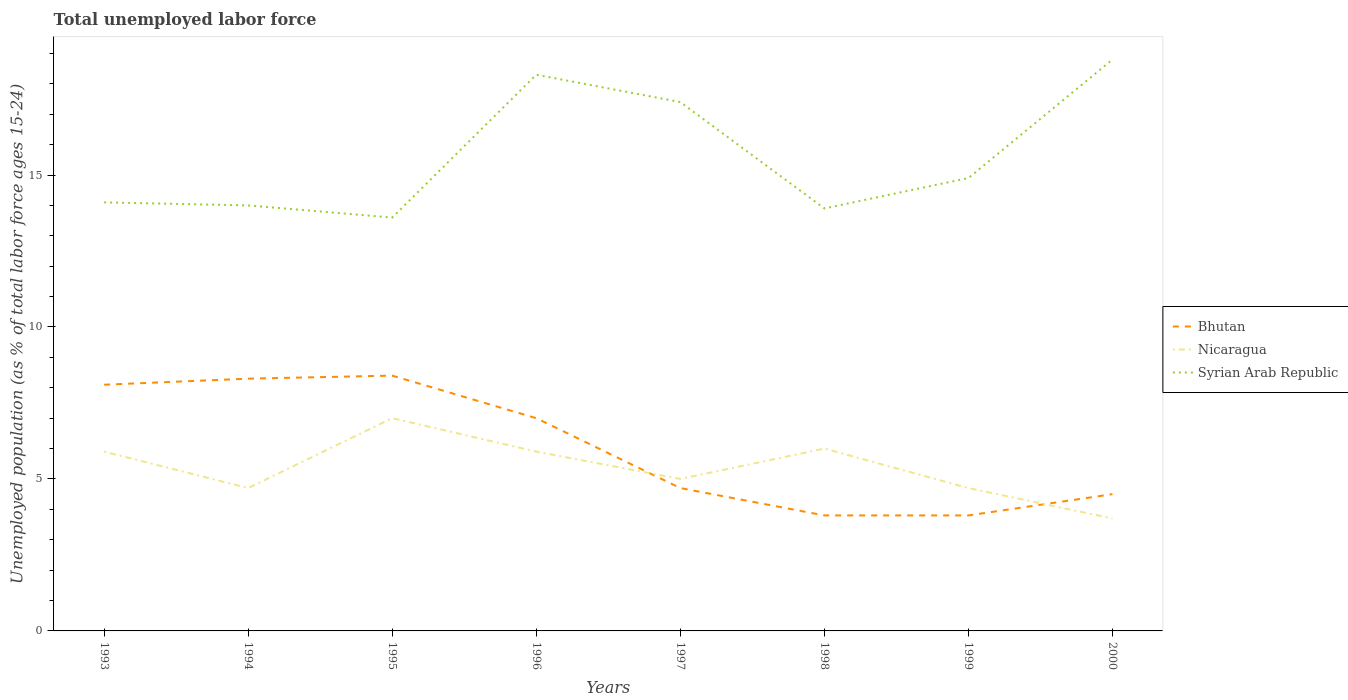How many different coloured lines are there?
Ensure brevity in your answer.  3. Is the number of lines equal to the number of legend labels?
Your answer should be very brief. Yes. Across all years, what is the maximum percentage of unemployed population in in Bhutan?
Provide a succinct answer. 3.8. In which year was the percentage of unemployed population in in Syrian Arab Republic maximum?
Make the answer very short. 1995. What is the total percentage of unemployed population in in Syrian Arab Republic in the graph?
Ensure brevity in your answer.  -5.2. What is the difference between the highest and the second highest percentage of unemployed population in in Bhutan?
Provide a succinct answer. 4.6. What is the difference between the highest and the lowest percentage of unemployed population in in Bhutan?
Provide a succinct answer. 4. How many years are there in the graph?
Keep it short and to the point. 8. What is the difference between two consecutive major ticks on the Y-axis?
Give a very brief answer. 5. Where does the legend appear in the graph?
Your response must be concise. Center right. How many legend labels are there?
Offer a very short reply. 3. What is the title of the graph?
Offer a terse response. Total unemployed labor force. What is the label or title of the Y-axis?
Provide a short and direct response. Unemployed population (as % of total labor force ages 15-24). What is the Unemployed population (as % of total labor force ages 15-24) of Bhutan in 1993?
Provide a short and direct response. 8.1. What is the Unemployed population (as % of total labor force ages 15-24) in Nicaragua in 1993?
Give a very brief answer. 5.9. What is the Unemployed population (as % of total labor force ages 15-24) in Syrian Arab Republic in 1993?
Offer a terse response. 14.1. What is the Unemployed population (as % of total labor force ages 15-24) of Bhutan in 1994?
Your answer should be very brief. 8.3. What is the Unemployed population (as % of total labor force ages 15-24) of Nicaragua in 1994?
Your response must be concise. 4.7. What is the Unemployed population (as % of total labor force ages 15-24) of Bhutan in 1995?
Offer a terse response. 8.4. What is the Unemployed population (as % of total labor force ages 15-24) in Syrian Arab Republic in 1995?
Offer a very short reply. 13.6. What is the Unemployed population (as % of total labor force ages 15-24) of Nicaragua in 1996?
Make the answer very short. 5.9. What is the Unemployed population (as % of total labor force ages 15-24) of Syrian Arab Republic in 1996?
Your answer should be very brief. 18.3. What is the Unemployed population (as % of total labor force ages 15-24) in Bhutan in 1997?
Your response must be concise. 4.7. What is the Unemployed population (as % of total labor force ages 15-24) of Syrian Arab Republic in 1997?
Provide a succinct answer. 17.4. What is the Unemployed population (as % of total labor force ages 15-24) of Bhutan in 1998?
Offer a terse response. 3.8. What is the Unemployed population (as % of total labor force ages 15-24) of Syrian Arab Republic in 1998?
Provide a succinct answer. 13.9. What is the Unemployed population (as % of total labor force ages 15-24) in Bhutan in 1999?
Your response must be concise. 3.8. What is the Unemployed population (as % of total labor force ages 15-24) of Nicaragua in 1999?
Keep it short and to the point. 4.7. What is the Unemployed population (as % of total labor force ages 15-24) of Syrian Arab Republic in 1999?
Your response must be concise. 14.9. What is the Unemployed population (as % of total labor force ages 15-24) in Bhutan in 2000?
Provide a succinct answer. 4.5. What is the Unemployed population (as % of total labor force ages 15-24) of Nicaragua in 2000?
Offer a terse response. 3.7. What is the Unemployed population (as % of total labor force ages 15-24) in Syrian Arab Republic in 2000?
Ensure brevity in your answer.  18.8. Across all years, what is the maximum Unemployed population (as % of total labor force ages 15-24) in Bhutan?
Offer a terse response. 8.4. Across all years, what is the maximum Unemployed population (as % of total labor force ages 15-24) in Syrian Arab Republic?
Provide a short and direct response. 18.8. Across all years, what is the minimum Unemployed population (as % of total labor force ages 15-24) in Bhutan?
Offer a terse response. 3.8. Across all years, what is the minimum Unemployed population (as % of total labor force ages 15-24) of Nicaragua?
Provide a short and direct response. 3.7. Across all years, what is the minimum Unemployed population (as % of total labor force ages 15-24) of Syrian Arab Republic?
Your answer should be very brief. 13.6. What is the total Unemployed population (as % of total labor force ages 15-24) of Bhutan in the graph?
Your response must be concise. 48.6. What is the total Unemployed population (as % of total labor force ages 15-24) in Nicaragua in the graph?
Keep it short and to the point. 42.9. What is the total Unemployed population (as % of total labor force ages 15-24) in Syrian Arab Republic in the graph?
Provide a succinct answer. 125. What is the difference between the Unemployed population (as % of total labor force ages 15-24) of Syrian Arab Republic in 1993 and that in 1994?
Your answer should be compact. 0.1. What is the difference between the Unemployed population (as % of total labor force ages 15-24) of Syrian Arab Republic in 1993 and that in 1995?
Give a very brief answer. 0.5. What is the difference between the Unemployed population (as % of total labor force ages 15-24) of Nicaragua in 1993 and that in 1996?
Provide a short and direct response. 0. What is the difference between the Unemployed population (as % of total labor force ages 15-24) in Bhutan in 1993 and that in 1997?
Ensure brevity in your answer.  3.4. What is the difference between the Unemployed population (as % of total labor force ages 15-24) of Nicaragua in 1993 and that in 1997?
Your answer should be very brief. 0.9. What is the difference between the Unemployed population (as % of total labor force ages 15-24) in Syrian Arab Republic in 1993 and that in 1997?
Keep it short and to the point. -3.3. What is the difference between the Unemployed population (as % of total labor force ages 15-24) of Nicaragua in 1993 and that in 1998?
Your response must be concise. -0.1. What is the difference between the Unemployed population (as % of total labor force ages 15-24) of Syrian Arab Republic in 1993 and that in 1998?
Provide a succinct answer. 0.2. What is the difference between the Unemployed population (as % of total labor force ages 15-24) in Bhutan in 1993 and that in 1999?
Your response must be concise. 4.3. What is the difference between the Unemployed population (as % of total labor force ages 15-24) in Nicaragua in 1993 and that in 1999?
Provide a short and direct response. 1.2. What is the difference between the Unemployed population (as % of total labor force ages 15-24) in Bhutan in 1993 and that in 2000?
Ensure brevity in your answer.  3.6. What is the difference between the Unemployed population (as % of total labor force ages 15-24) of Nicaragua in 1993 and that in 2000?
Ensure brevity in your answer.  2.2. What is the difference between the Unemployed population (as % of total labor force ages 15-24) in Syrian Arab Republic in 1993 and that in 2000?
Provide a succinct answer. -4.7. What is the difference between the Unemployed population (as % of total labor force ages 15-24) in Nicaragua in 1994 and that in 1995?
Provide a short and direct response. -2.3. What is the difference between the Unemployed population (as % of total labor force ages 15-24) of Syrian Arab Republic in 1994 and that in 1995?
Ensure brevity in your answer.  0.4. What is the difference between the Unemployed population (as % of total labor force ages 15-24) of Bhutan in 1994 and that in 1996?
Offer a very short reply. 1.3. What is the difference between the Unemployed population (as % of total labor force ages 15-24) of Nicaragua in 1994 and that in 1996?
Ensure brevity in your answer.  -1.2. What is the difference between the Unemployed population (as % of total labor force ages 15-24) in Syrian Arab Republic in 1994 and that in 1996?
Give a very brief answer. -4.3. What is the difference between the Unemployed population (as % of total labor force ages 15-24) of Nicaragua in 1994 and that in 1997?
Your answer should be very brief. -0.3. What is the difference between the Unemployed population (as % of total labor force ages 15-24) of Syrian Arab Republic in 1994 and that in 1997?
Make the answer very short. -3.4. What is the difference between the Unemployed population (as % of total labor force ages 15-24) of Bhutan in 1994 and that in 1998?
Your response must be concise. 4.5. What is the difference between the Unemployed population (as % of total labor force ages 15-24) of Nicaragua in 1994 and that in 1998?
Offer a very short reply. -1.3. What is the difference between the Unemployed population (as % of total labor force ages 15-24) in Syrian Arab Republic in 1994 and that in 1998?
Provide a succinct answer. 0.1. What is the difference between the Unemployed population (as % of total labor force ages 15-24) of Bhutan in 1994 and that in 1999?
Provide a short and direct response. 4.5. What is the difference between the Unemployed population (as % of total labor force ages 15-24) of Nicaragua in 1994 and that in 1999?
Ensure brevity in your answer.  0. What is the difference between the Unemployed population (as % of total labor force ages 15-24) in Bhutan in 1994 and that in 2000?
Provide a succinct answer. 3.8. What is the difference between the Unemployed population (as % of total labor force ages 15-24) of Nicaragua in 1994 and that in 2000?
Offer a terse response. 1. What is the difference between the Unemployed population (as % of total labor force ages 15-24) in Nicaragua in 1995 and that in 1996?
Ensure brevity in your answer.  1.1. What is the difference between the Unemployed population (as % of total labor force ages 15-24) in Bhutan in 1995 and that in 1997?
Keep it short and to the point. 3.7. What is the difference between the Unemployed population (as % of total labor force ages 15-24) in Syrian Arab Republic in 1995 and that in 1998?
Keep it short and to the point. -0.3. What is the difference between the Unemployed population (as % of total labor force ages 15-24) in Bhutan in 1995 and that in 1999?
Give a very brief answer. 4.6. What is the difference between the Unemployed population (as % of total labor force ages 15-24) in Syrian Arab Republic in 1995 and that in 1999?
Your response must be concise. -1.3. What is the difference between the Unemployed population (as % of total labor force ages 15-24) of Bhutan in 1995 and that in 2000?
Give a very brief answer. 3.9. What is the difference between the Unemployed population (as % of total labor force ages 15-24) in Syrian Arab Republic in 1995 and that in 2000?
Provide a short and direct response. -5.2. What is the difference between the Unemployed population (as % of total labor force ages 15-24) of Syrian Arab Republic in 1996 and that in 1998?
Ensure brevity in your answer.  4.4. What is the difference between the Unemployed population (as % of total labor force ages 15-24) of Bhutan in 1996 and that in 1999?
Give a very brief answer. 3.2. What is the difference between the Unemployed population (as % of total labor force ages 15-24) in Bhutan in 1996 and that in 2000?
Provide a short and direct response. 2.5. What is the difference between the Unemployed population (as % of total labor force ages 15-24) in Syrian Arab Republic in 1996 and that in 2000?
Ensure brevity in your answer.  -0.5. What is the difference between the Unemployed population (as % of total labor force ages 15-24) of Bhutan in 1997 and that in 1998?
Offer a very short reply. 0.9. What is the difference between the Unemployed population (as % of total labor force ages 15-24) of Nicaragua in 1997 and that in 1998?
Give a very brief answer. -1. What is the difference between the Unemployed population (as % of total labor force ages 15-24) in Syrian Arab Republic in 1997 and that in 1998?
Offer a terse response. 3.5. What is the difference between the Unemployed population (as % of total labor force ages 15-24) of Bhutan in 1997 and that in 1999?
Your response must be concise. 0.9. What is the difference between the Unemployed population (as % of total labor force ages 15-24) in Nicaragua in 1997 and that in 1999?
Your answer should be very brief. 0.3. What is the difference between the Unemployed population (as % of total labor force ages 15-24) of Bhutan in 1997 and that in 2000?
Make the answer very short. 0.2. What is the difference between the Unemployed population (as % of total labor force ages 15-24) in Nicaragua in 1997 and that in 2000?
Keep it short and to the point. 1.3. What is the difference between the Unemployed population (as % of total labor force ages 15-24) in Bhutan in 1998 and that in 1999?
Your answer should be very brief. 0. What is the difference between the Unemployed population (as % of total labor force ages 15-24) in Nicaragua in 1998 and that in 2000?
Keep it short and to the point. 2.3. What is the difference between the Unemployed population (as % of total labor force ages 15-24) in Syrian Arab Republic in 1998 and that in 2000?
Your answer should be very brief. -4.9. What is the difference between the Unemployed population (as % of total labor force ages 15-24) in Bhutan in 1999 and that in 2000?
Give a very brief answer. -0.7. What is the difference between the Unemployed population (as % of total labor force ages 15-24) of Bhutan in 1993 and the Unemployed population (as % of total labor force ages 15-24) of Nicaragua in 1995?
Your answer should be compact. 1.1. What is the difference between the Unemployed population (as % of total labor force ages 15-24) in Nicaragua in 1993 and the Unemployed population (as % of total labor force ages 15-24) in Syrian Arab Republic in 1995?
Keep it short and to the point. -7.7. What is the difference between the Unemployed population (as % of total labor force ages 15-24) in Bhutan in 1993 and the Unemployed population (as % of total labor force ages 15-24) in Nicaragua in 1996?
Provide a short and direct response. 2.2. What is the difference between the Unemployed population (as % of total labor force ages 15-24) in Bhutan in 1993 and the Unemployed population (as % of total labor force ages 15-24) in Syrian Arab Republic in 1997?
Your answer should be very brief. -9.3. What is the difference between the Unemployed population (as % of total labor force ages 15-24) of Nicaragua in 1993 and the Unemployed population (as % of total labor force ages 15-24) of Syrian Arab Republic in 1997?
Provide a short and direct response. -11.5. What is the difference between the Unemployed population (as % of total labor force ages 15-24) in Bhutan in 1993 and the Unemployed population (as % of total labor force ages 15-24) in Nicaragua in 1998?
Provide a succinct answer. 2.1. What is the difference between the Unemployed population (as % of total labor force ages 15-24) of Bhutan in 1993 and the Unemployed population (as % of total labor force ages 15-24) of Nicaragua in 1999?
Provide a short and direct response. 3.4. What is the difference between the Unemployed population (as % of total labor force ages 15-24) of Bhutan in 1993 and the Unemployed population (as % of total labor force ages 15-24) of Syrian Arab Republic in 1999?
Keep it short and to the point. -6.8. What is the difference between the Unemployed population (as % of total labor force ages 15-24) of Bhutan in 1993 and the Unemployed population (as % of total labor force ages 15-24) of Syrian Arab Republic in 2000?
Provide a succinct answer. -10.7. What is the difference between the Unemployed population (as % of total labor force ages 15-24) of Bhutan in 1994 and the Unemployed population (as % of total labor force ages 15-24) of Syrian Arab Republic in 1995?
Your answer should be very brief. -5.3. What is the difference between the Unemployed population (as % of total labor force ages 15-24) in Nicaragua in 1994 and the Unemployed population (as % of total labor force ages 15-24) in Syrian Arab Republic in 1997?
Your answer should be very brief. -12.7. What is the difference between the Unemployed population (as % of total labor force ages 15-24) in Bhutan in 1994 and the Unemployed population (as % of total labor force ages 15-24) in Nicaragua in 1998?
Offer a very short reply. 2.3. What is the difference between the Unemployed population (as % of total labor force ages 15-24) of Bhutan in 1994 and the Unemployed population (as % of total labor force ages 15-24) of Syrian Arab Republic in 1998?
Keep it short and to the point. -5.6. What is the difference between the Unemployed population (as % of total labor force ages 15-24) in Bhutan in 1994 and the Unemployed population (as % of total labor force ages 15-24) in Nicaragua in 1999?
Ensure brevity in your answer.  3.6. What is the difference between the Unemployed population (as % of total labor force ages 15-24) in Bhutan in 1994 and the Unemployed population (as % of total labor force ages 15-24) in Syrian Arab Republic in 1999?
Offer a terse response. -6.6. What is the difference between the Unemployed population (as % of total labor force ages 15-24) in Bhutan in 1994 and the Unemployed population (as % of total labor force ages 15-24) in Nicaragua in 2000?
Your answer should be very brief. 4.6. What is the difference between the Unemployed population (as % of total labor force ages 15-24) of Bhutan in 1994 and the Unemployed population (as % of total labor force ages 15-24) of Syrian Arab Republic in 2000?
Your answer should be compact. -10.5. What is the difference between the Unemployed population (as % of total labor force ages 15-24) in Nicaragua in 1994 and the Unemployed population (as % of total labor force ages 15-24) in Syrian Arab Republic in 2000?
Your answer should be compact. -14.1. What is the difference between the Unemployed population (as % of total labor force ages 15-24) of Bhutan in 1995 and the Unemployed population (as % of total labor force ages 15-24) of Nicaragua in 1996?
Your response must be concise. 2.5. What is the difference between the Unemployed population (as % of total labor force ages 15-24) in Bhutan in 1995 and the Unemployed population (as % of total labor force ages 15-24) in Syrian Arab Republic in 1997?
Keep it short and to the point. -9. What is the difference between the Unemployed population (as % of total labor force ages 15-24) in Bhutan in 1995 and the Unemployed population (as % of total labor force ages 15-24) in Nicaragua in 2000?
Your response must be concise. 4.7. What is the difference between the Unemployed population (as % of total labor force ages 15-24) of Bhutan in 1995 and the Unemployed population (as % of total labor force ages 15-24) of Syrian Arab Republic in 2000?
Keep it short and to the point. -10.4. What is the difference between the Unemployed population (as % of total labor force ages 15-24) of Bhutan in 1996 and the Unemployed population (as % of total labor force ages 15-24) of Syrian Arab Republic in 1997?
Keep it short and to the point. -10.4. What is the difference between the Unemployed population (as % of total labor force ages 15-24) of Nicaragua in 1996 and the Unemployed population (as % of total labor force ages 15-24) of Syrian Arab Republic in 1997?
Your response must be concise. -11.5. What is the difference between the Unemployed population (as % of total labor force ages 15-24) in Bhutan in 1996 and the Unemployed population (as % of total labor force ages 15-24) in Nicaragua in 1998?
Your answer should be compact. 1. What is the difference between the Unemployed population (as % of total labor force ages 15-24) in Bhutan in 1996 and the Unemployed population (as % of total labor force ages 15-24) in Nicaragua in 2000?
Your answer should be compact. 3.3. What is the difference between the Unemployed population (as % of total labor force ages 15-24) of Nicaragua in 1996 and the Unemployed population (as % of total labor force ages 15-24) of Syrian Arab Republic in 2000?
Make the answer very short. -12.9. What is the difference between the Unemployed population (as % of total labor force ages 15-24) in Bhutan in 1997 and the Unemployed population (as % of total labor force ages 15-24) in Nicaragua in 1998?
Your answer should be compact. -1.3. What is the difference between the Unemployed population (as % of total labor force ages 15-24) of Bhutan in 1997 and the Unemployed population (as % of total labor force ages 15-24) of Syrian Arab Republic in 1998?
Offer a terse response. -9.2. What is the difference between the Unemployed population (as % of total labor force ages 15-24) in Bhutan in 1997 and the Unemployed population (as % of total labor force ages 15-24) in Nicaragua in 1999?
Your answer should be compact. 0. What is the difference between the Unemployed population (as % of total labor force ages 15-24) in Bhutan in 1997 and the Unemployed population (as % of total labor force ages 15-24) in Syrian Arab Republic in 1999?
Provide a succinct answer. -10.2. What is the difference between the Unemployed population (as % of total labor force ages 15-24) of Nicaragua in 1997 and the Unemployed population (as % of total labor force ages 15-24) of Syrian Arab Republic in 1999?
Offer a terse response. -9.9. What is the difference between the Unemployed population (as % of total labor force ages 15-24) of Bhutan in 1997 and the Unemployed population (as % of total labor force ages 15-24) of Nicaragua in 2000?
Give a very brief answer. 1. What is the difference between the Unemployed population (as % of total labor force ages 15-24) in Bhutan in 1997 and the Unemployed population (as % of total labor force ages 15-24) in Syrian Arab Republic in 2000?
Your answer should be very brief. -14.1. What is the difference between the Unemployed population (as % of total labor force ages 15-24) in Nicaragua in 1998 and the Unemployed population (as % of total labor force ages 15-24) in Syrian Arab Republic in 1999?
Your answer should be very brief. -8.9. What is the difference between the Unemployed population (as % of total labor force ages 15-24) of Bhutan in 1999 and the Unemployed population (as % of total labor force ages 15-24) of Nicaragua in 2000?
Offer a very short reply. 0.1. What is the difference between the Unemployed population (as % of total labor force ages 15-24) of Bhutan in 1999 and the Unemployed population (as % of total labor force ages 15-24) of Syrian Arab Republic in 2000?
Provide a short and direct response. -15. What is the difference between the Unemployed population (as % of total labor force ages 15-24) of Nicaragua in 1999 and the Unemployed population (as % of total labor force ages 15-24) of Syrian Arab Republic in 2000?
Give a very brief answer. -14.1. What is the average Unemployed population (as % of total labor force ages 15-24) of Bhutan per year?
Give a very brief answer. 6.08. What is the average Unemployed population (as % of total labor force ages 15-24) of Nicaragua per year?
Your response must be concise. 5.36. What is the average Unemployed population (as % of total labor force ages 15-24) in Syrian Arab Republic per year?
Ensure brevity in your answer.  15.62. In the year 1993, what is the difference between the Unemployed population (as % of total labor force ages 15-24) in Bhutan and Unemployed population (as % of total labor force ages 15-24) in Nicaragua?
Make the answer very short. 2.2. In the year 1994, what is the difference between the Unemployed population (as % of total labor force ages 15-24) in Bhutan and Unemployed population (as % of total labor force ages 15-24) in Nicaragua?
Give a very brief answer. 3.6. In the year 1995, what is the difference between the Unemployed population (as % of total labor force ages 15-24) of Nicaragua and Unemployed population (as % of total labor force ages 15-24) of Syrian Arab Republic?
Offer a terse response. -6.6. In the year 1996, what is the difference between the Unemployed population (as % of total labor force ages 15-24) in Bhutan and Unemployed population (as % of total labor force ages 15-24) in Nicaragua?
Ensure brevity in your answer.  1.1. In the year 1996, what is the difference between the Unemployed population (as % of total labor force ages 15-24) in Bhutan and Unemployed population (as % of total labor force ages 15-24) in Syrian Arab Republic?
Give a very brief answer. -11.3. In the year 1996, what is the difference between the Unemployed population (as % of total labor force ages 15-24) in Nicaragua and Unemployed population (as % of total labor force ages 15-24) in Syrian Arab Republic?
Provide a succinct answer. -12.4. In the year 1997, what is the difference between the Unemployed population (as % of total labor force ages 15-24) of Bhutan and Unemployed population (as % of total labor force ages 15-24) of Syrian Arab Republic?
Ensure brevity in your answer.  -12.7. In the year 1997, what is the difference between the Unemployed population (as % of total labor force ages 15-24) in Nicaragua and Unemployed population (as % of total labor force ages 15-24) in Syrian Arab Republic?
Provide a short and direct response. -12.4. In the year 1998, what is the difference between the Unemployed population (as % of total labor force ages 15-24) in Bhutan and Unemployed population (as % of total labor force ages 15-24) in Syrian Arab Republic?
Provide a short and direct response. -10.1. In the year 1999, what is the difference between the Unemployed population (as % of total labor force ages 15-24) of Bhutan and Unemployed population (as % of total labor force ages 15-24) of Nicaragua?
Make the answer very short. -0.9. In the year 1999, what is the difference between the Unemployed population (as % of total labor force ages 15-24) of Bhutan and Unemployed population (as % of total labor force ages 15-24) of Syrian Arab Republic?
Keep it short and to the point. -11.1. In the year 2000, what is the difference between the Unemployed population (as % of total labor force ages 15-24) in Bhutan and Unemployed population (as % of total labor force ages 15-24) in Nicaragua?
Your answer should be very brief. 0.8. In the year 2000, what is the difference between the Unemployed population (as % of total labor force ages 15-24) in Bhutan and Unemployed population (as % of total labor force ages 15-24) in Syrian Arab Republic?
Provide a succinct answer. -14.3. In the year 2000, what is the difference between the Unemployed population (as % of total labor force ages 15-24) of Nicaragua and Unemployed population (as % of total labor force ages 15-24) of Syrian Arab Republic?
Provide a short and direct response. -15.1. What is the ratio of the Unemployed population (as % of total labor force ages 15-24) of Bhutan in 1993 to that in 1994?
Offer a very short reply. 0.98. What is the ratio of the Unemployed population (as % of total labor force ages 15-24) in Nicaragua in 1993 to that in 1994?
Make the answer very short. 1.26. What is the ratio of the Unemployed population (as % of total labor force ages 15-24) in Syrian Arab Republic in 1993 to that in 1994?
Make the answer very short. 1.01. What is the ratio of the Unemployed population (as % of total labor force ages 15-24) in Bhutan in 1993 to that in 1995?
Offer a terse response. 0.96. What is the ratio of the Unemployed population (as % of total labor force ages 15-24) in Nicaragua in 1993 to that in 1995?
Your answer should be compact. 0.84. What is the ratio of the Unemployed population (as % of total labor force ages 15-24) in Syrian Arab Republic in 1993 to that in 1995?
Offer a terse response. 1.04. What is the ratio of the Unemployed population (as % of total labor force ages 15-24) of Bhutan in 1993 to that in 1996?
Offer a very short reply. 1.16. What is the ratio of the Unemployed population (as % of total labor force ages 15-24) in Nicaragua in 1993 to that in 1996?
Ensure brevity in your answer.  1. What is the ratio of the Unemployed population (as % of total labor force ages 15-24) in Syrian Arab Republic in 1993 to that in 1996?
Offer a terse response. 0.77. What is the ratio of the Unemployed population (as % of total labor force ages 15-24) in Bhutan in 1993 to that in 1997?
Your answer should be very brief. 1.72. What is the ratio of the Unemployed population (as % of total labor force ages 15-24) of Nicaragua in 1993 to that in 1997?
Your answer should be very brief. 1.18. What is the ratio of the Unemployed population (as % of total labor force ages 15-24) in Syrian Arab Republic in 1993 to that in 1997?
Offer a very short reply. 0.81. What is the ratio of the Unemployed population (as % of total labor force ages 15-24) in Bhutan in 1993 to that in 1998?
Your answer should be very brief. 2.13. What is the ratio of the Unemployed population (as % of total labor force ages 15-24) of Nicaragua in 1993 to that in 1998?
Keep it short and to the point. 0.98. What is the ratio of the Unemployed population (as % of total labor force ages 15-24) in Syrian Arab Republic in 1993 to that in 1998?
Ensure brevity in your answer.  1.01. What is the ratio of the Unemployed population (as % of total labor force ages 15-24) of Bhutan in 1993 to that in 1999?
Offer a very short reply. 2.13. What is the ratio of the Unemployed population (as % of total labor force ages 15-24) in Nicaragua in 1993 to that in 1999?
Give a very brief answer. 1.26. What is the ratio of the Unemployed population (as % of total labor force ages 15-24) of Syrian Arab Republic in 1993 to that in 1999?
Provide a succinct answer. 0.95. What is the ratio of the Unemployed population (as % of total labor force ages 15-24) in Bhutan in 1993 to that in 2000?
Offer a very short reply. 1.8. What is the ratio of the Unemployed population (as % of total labor force ages 15-24) in Nicaragua in 1993 to that in 2000?
Your answer should be very brief. 1.59. What is the ratio of the Unemployed population (as % of total labor force ages 15-24) in Syrian Arab Republic in 1993 to that in 2000?
Provide a succinct answer. 0.75. What is the ratio of the Unemployed population (as % of total labor force ages 15-24) in Bhutan in 1994 to that in 1995?
Provide a succinct answer. 0.99. What is the ratio of the Unemployed population (as % of total labor force ages 15-24) in Nicaragua in 1994 to that in 1995?
Make the answer very short. 0.67. What is the ratio of the Unemployed population (as % of total labor force ages 15-24) in Syrian Arab Republic in 1994 to that in 1995?
Give a very brief answer. 1.03. What is the ratio of the Unemployed population (as % of total labor force ages 15-24) in Bhutan in 1994 to that in 1996?
Ensure brevity in your answer.  1.19. What is the ratio of the Unemployed population (as % of total labor force ages 15-24) in Nicaragua in 1994 to that in 1996?
Make the answer very short. 0.8. What is the ratio of the Unemployed population (as % of total labor force ages 15-24) of Syrian Arab Republic in 1994 to that in 1996?
Give a very brief answer. 0.77. What is the ratio of the Unemployed population (as % of total labor force ages 15-24) of Bhutan in 1994 to that in 1997?
Your answer should be compact. 1.77. What is the ratio of the Unemployed population (as % of total labor force ages 15-24) of Syrian Arab Republic in 1994 to that in 1997?
Keep it short and to the point. 0.8. What is the ratio of the Unemployed population (as % of total labor force ages 15-24) of Bhutan in 1994 to that in 1998?
Provide a succinct answer. 2.18. What is the ratio of the Unemployed population (as % of total labor force ages 15-24) in Nicaragua in 1994 to that in 1998?
Provide a short and direct response. 0.78. What is the ratio of the Unemployed population (as % of total labor force ages 15-24) of Bhutan in 1994 to that in 1999?
Offer a terse response. 2.18. What is the ratio of the Unemployed population (as % of total labor force ages 15-24) in Nicaragua in 1994 to that in 1999?
Give a very brief answer. 1. What is the ratio of the Unemployed population (as % of total labor force ages 15-24) of Syrian Arab Republic in 1994 to that in 1999?
Give a very brief answer. 0.94. What is the ratio of the Unemployed population (as % of total labor force ages 15-24) in Bhutan in 1994 to that in 2000?
Offer a terse response. 1.84. What is the ratio of the Unemployed population (as % of total labor force ages 15-24) in Nicaragua in 1994 to that in 2000?
Offer a very short reply. 1.27. What is the ratio of the Unemployed population (as % of total labor force ages 15-24) in Syrian Arab Republic in 1994 to that in 2000?
Your answer should be very brief. 0.74. What is the ratio of the Unemployed population (as % of total labor force ages 15-24) of Bhutan in 1995 to that in 1996?
Give a very brief answer. 1.2. What is the ratio of the Unemployed population (as % of total labor force ages 15-24) of Nicaragua in 1995 to that in 1996?
Offer a terse response. 1.19. What is the ratio of the Unemployed population (as % of total labor force ages 15-24) in Syrian Arab Republic in 1995 to that in 1996?
Offer a terse response. 0.74. What is the ratio of the Unemployed population (as % of total labor force ages 15-24) in Bhutan in 1995 to that in 1997?
Keep it short and to the point. 1.79. What is the ratio of the Unemployed population (as % of total labor force ages 15-24) of Nicaragua in 1995 to that in 1997?
Your answer should be very brief. 1.4. What is the ratio of the Unemployed population (as % of total labor force ages 15-24) of Syrian Arab Republic in 1995 to that in 1997?
Keep it short and to the point. 0.78. What is the ratio of the Unemployed population (as % of total labor force ages 15-24) of Bhutan in 1995 to that in 1998?
Provide a short and direct response. 2.21. What is the ratio of the Unemployed population (as % of total labor force ages 15-24) in Syrian Arab Republic in 1995 to that in 1998?
Your answer should be compact. 0.98. What is the ratio of the Unemployed population (as % of total labor force ages 15-24) in Bhutan in 1995 to that in 1999?
Keep it short and to the point. 2.21. What is the ratio of the Unemployed population (as % of total labor force ages 15-24) in Nicaragua in 1995 to that in 1999?
Provide a short and direct response. 1.49. What is the ratio of the Unemployed population (as % of total labor force ages 15-24) of Syrian Arab Republic in 1995 to that in 1999?
Provide a short and direct response. 0.91. What is the ratio of the Unemployed population (as % of total labor force ages 15-24) in Bhutan in 1995 to that in 2000?
Keep it short and to the point. 1.87. What is the ratio of the Unemployed population (as % of total labor force ages 15-24) of Nicaragua in 1995 to that in 2000?
Make the answer very short. 1.89. What is the ratio of the Unemployed population (as % of total labor force ages 15-24) in Syrian Arab Republic in 1995 to that in 2000?
Provide a short and direct response. 0.72. What is the ratio of the Unemployed population (as % of total labor force ages 15-24) of Bhutan in 1996 to that in 1997?
Offer a terse response. 1.49. What is the ratio of the Unemployed population (as % of total labor force ages 15-24) in Nicaragua in 1996 to that in 1997?
Keep it short and to the point. 1.18. What is the ratio of the Unemployed population (as % of total labor force ages 15-24) in Syrian Arab Republic in 1996 to that in 1997?
Keep it short and to the point. 1.05. What is the ratio of the Unemployed population (as % of total labor force ages 15-24) of Bhutan in 1996 to that in 1998?
Ensure brevity in your answer.  1.84. What is the ratio of the Unemployed population (as % of total labor force ages 15-24) of Nicaragua in 1996 to that in 1998?
Give a very brief answer. 0.98. What is the ratio of the Unemployed population (as % of total labor force ages 15-24) in Syrian Arab Republic in 1996 to that in 1998?
Your answer should be compact. 1.32. What is the ratio of the Unemployed population (as % of total labor force ages 15-24) in Bhutan in 1996 to that in 1999?
Your answer should be compact. 1.84. What is the ratio of the Unemployed population (as % of total labor force ages 15-24) in Nicaragua in 1996 to that in 1999?
Offer a terse response. 1.26. What is the ratio of the Unemployed population (as % of total labor force ages 15-24) of Syrian Arab Republic in 1996 to that in 1999?
Your answer should be very brief. 1.23. What is the ratio of the Unemployed population (as % of total labor force ages 15-24) of Bhutan in 1996 to that in 2000?
Ensure brevity in your answer.  1.56. What is the ratio of the Unemployed population (as % of total labor force ages 15-24) of Nicaragua in 1996 to that in 2000?
Offer a very short reply. 1.59. What is the ratio of the Unemployed population (as % of total labor force ages 15-24) in Syrian Arab Republic in 1996 to that in 2000?
Offer a terse response. 0.97. What is the ratio of the Unemployed population (as % of total labor force ages 15-24) in Bhutan in 1997 to that in 1998?
Your response must be concise. 1.24. What is the ratio of the Unemployed population (as % of total labor force ages 15-24) in Syrian Arab Republic in 1997 to that in 1998?
Offer a terse response. 1.25. What is the ratio of the Unemployed population (as % of total labor force ages 15-24) in Bhutan in 1997 to that in 1999?
Give a very brief answer. 1.24. What is the ratio of the Unemployed population (as % of total labor force ages 15-24) in Nicaragua in 1997 to that in 1999?
Give a very brief answer. 1.06. What is the ratio of the Unemployed population (as % of total labor force ages 15-24) in Syrian Arab Republic in 1997 to that in 1999?
Offer a very short reply. 1.17. What is the ratio of the Unemployed population (as % of total labor force ages 15-24) in Bhutan in 1997 to that in 2000?
Your answer should be compact. 1.04. What is the ratio of the Unemployed population (as % of total labor force ages 15-24) of Nicaragua in 1997 to that in 2000?
Your answer should be very brief. 1.35. What is the ratio of the Unemployed population (as % of total labor force ages 15-24) of Syrian Arab Republic in 1997 to that in 2000?
Your response must be concise. 0.93. What is the ratio of the Unemployed population (as % of total labor force ages 15-24) in Bhutan in 1998 to that in 1999?
Your answer should be compact. 1. What is the ratio of the Unemployed population (as % of total labor force ages 15-24) of Nicaragua in 1998 to that in 1999?
Give a very brief answer. 1.28. What is the ratio of the Unemployed population (as % of total labor force ages 15-24) in Syrian Arab Republic in 1998 to that in 1999?
Offer a terse response. 0.93. What is the ratio of the Unemployed population (as % of total labor force ages 15-24) in Bhutan in 1998 to that in 2000?
Your response must be concise. 0.84. What is the ratio of the Unemployed population (as % of total labor force ages 15-24) of Nicaragua in 1998 to that in 2000?
Give a very brief answer. 1.62. What is the ratio of the Unemployed population (as % of total labor force ages 15-24) of Syrian Arab Republic in 1998 to that in 2000?
Offer a terse response. 0.74. What is the ratio of the Unemployed population (as % of total labor force ages 15-24) of Bhutan in 1999 to that in 2000?
Your answer should be compact. 0.84. What is the ratio of the Unemployed population (as % of total labor force ages 15-24) in Nicaragua in 1999 to that in 2000?
Provide a succinct answer. 1.27. What is the ratio of the Unemployed population (as % of total labor force ages 15-24) in Syrian Arab Republic in 1999 to that in 2000?
Give a very brief answer. 0.79. What is the difference between the highest and the second highest Unemployed population (as % of total labor force ages 15-24) in Bhutan?
Provide a short and direct response. 0.1. What is the difference between the highest and the second highest Unemployed population (as % of total labor force ages 15-24) of Nicaragua?
Make the answer very short. 1. What is the difference between the highest and the lowest Unemployed population (as % of total labor force ages 15-24) in Bhutan?
Ensure brevity in your answer.  4.6. What is the difference between the highest and the lowest Unemployed population (as % of total labor force ages 15-24) of Nicaragua?
Your answer should be very brief. 3.3. What is the difference between the highest and the lowest Unemployed population (as % of total labor force ages 15-24) in Syrian Arab Republic?
Provide a short and direct response. 5.2. 